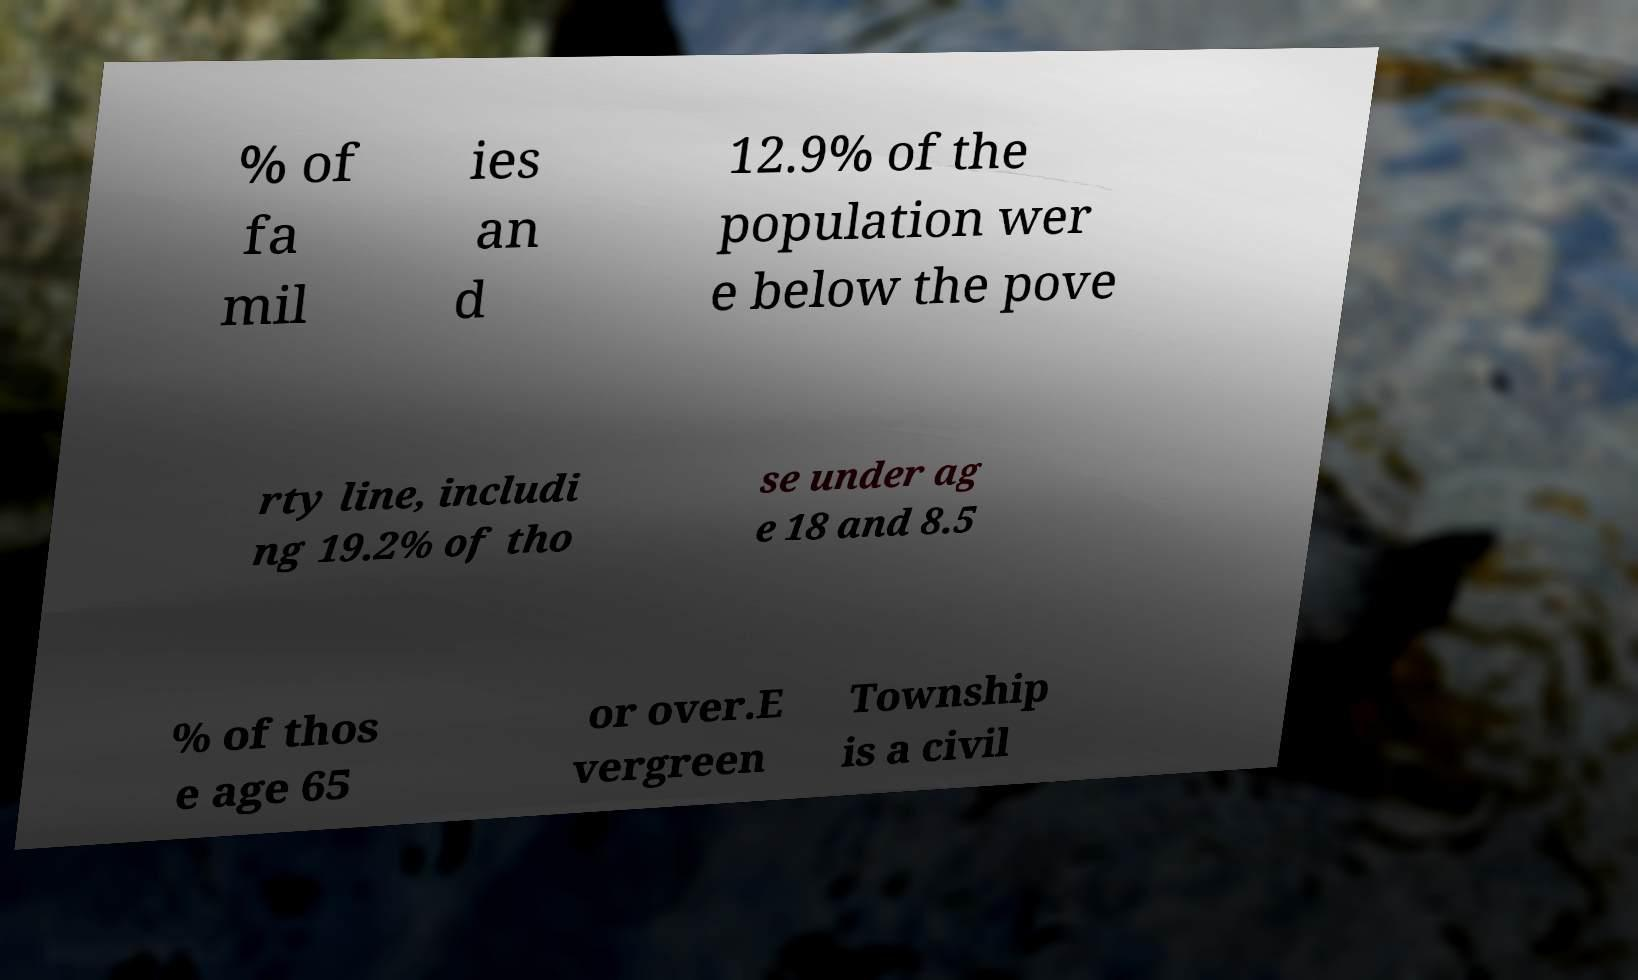For documentation purposes, I need the text within this image transcribed. Could you provide that? % of fa mil ies an d 12.9% of the population wer e below the pove rty line, includi ng 19.2% of tho se under ag e 18 and 8.5 % of thos e age 65 or over.E vergreen Township is a civil 